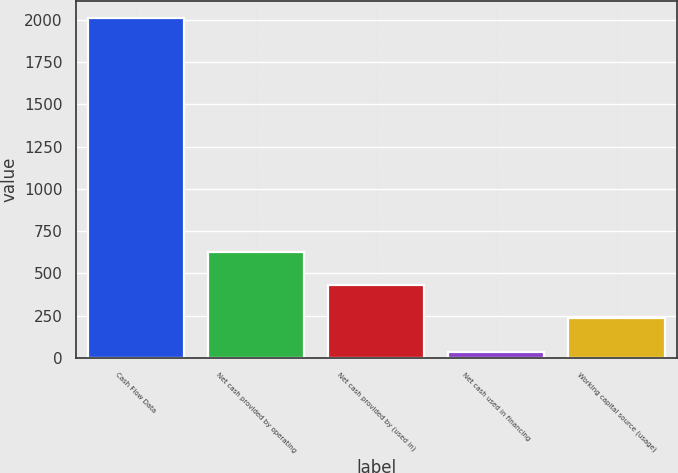Convert chart. <chart><loc_0><loc_0><loc_500><loc_500><bar_chart><fcel>Cash Flow Data<fcel>Net cash provided by operating<fcel>Net cash provided by (used in)<fcel>Net cash used in financing<fcel>Working capital source (usage)<nl><fcel>2007<fcel>628.21<fcel>431.24<fcel>37.3<fcel>234.27<nl></chart> 